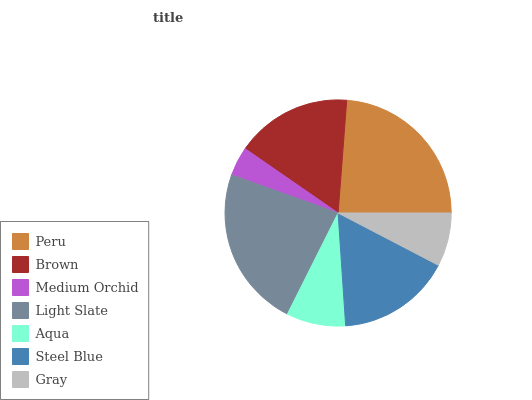Is Medium Orchid the minimum?
Answer yes or no. Yes. Is Peru the maximum?
Answer yes or no. Yes. Is Brown the minimum?
Answer yes or no. No. Is Brown the maximum?
Answer yes or no. No. Is Peru greater than Brown?
Answer yes or no. Yes. Is Brown less than Peru?
Answer yes or no. Yes. Is Brown greater than Peru?
Answer yes or no. No. Is Peru less than Brown?
Answer yes or no. No. Is Steel Blue the high median?
Answer yes or no. Yes. Is Steel Blue the low median?
Answer yes or no. Yes. Is Light Slate the high median?
Answer yes or no. No. Is Medium Orchid the low median?
Answer yes or no. No. 